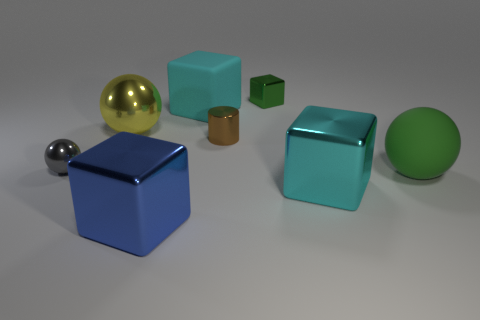Subtract all big green spheres. How many spheres are left? 2 Subtract all yellow spheres. How many spheres are left? 2 Add 2 gray shiny things. How many objects exist? 10 Subtract all cylinders. How many objects are left? 7 Subtract 3 balls. How many balls are left? 0 Subtract all yellow cylinders. Subtract all red cubes. How many cylinders are left? 1 Subtract all gray balls. How many gray cylinders are left? 0 Subtract all small brown objects. Subtract all big blue things. How many objects are left? 6 Add 7 small gray spheres. How many small gray spheres are left? 8 Add 7 large cyan objects. How many large cyan objects exist? 9 